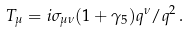<formula> <loc_0><loc_0><loc_500><loc_500>T _ { \mu } = i \sigma _ { \mu \nu } ( 1 + \gamma _ { 5 } ) q ^ { \nu } / q ^ { 2 } \, .</formula> 